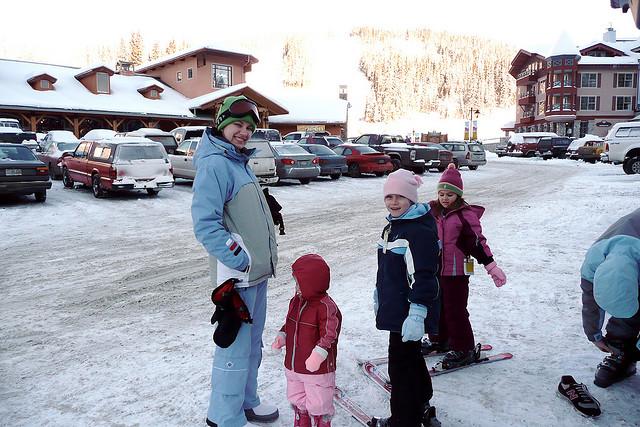Where is this?
Be succinct. Colorado. What is covering the ground?
Write a very short answer. Snow. Who is wearing pink mittens?
Give a very brief answer. Little girls. What color is the shoe?
Answer briefly. Black. 